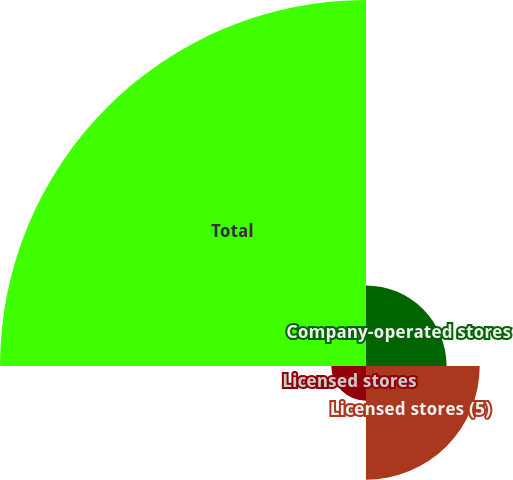Convert chart. <chart><loc_0><loc_0><loc_500><loc_500><pie_chart><fcel>Company-operated stores<fcel>Licensed stores (5)<fcel>Licensed stores<fcel>Total<nl><fcel>13.54%<fcel>19.11%<fcel>5.84%<fcel>61.51%<nl></chart> 